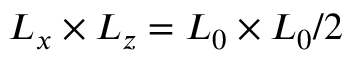<formula> <loc_0><loc_0><loc_500><loc_500>L _ { x } \times L _ { z } = L _ { 0 } \times L _ { 0 } / 2</formula> 